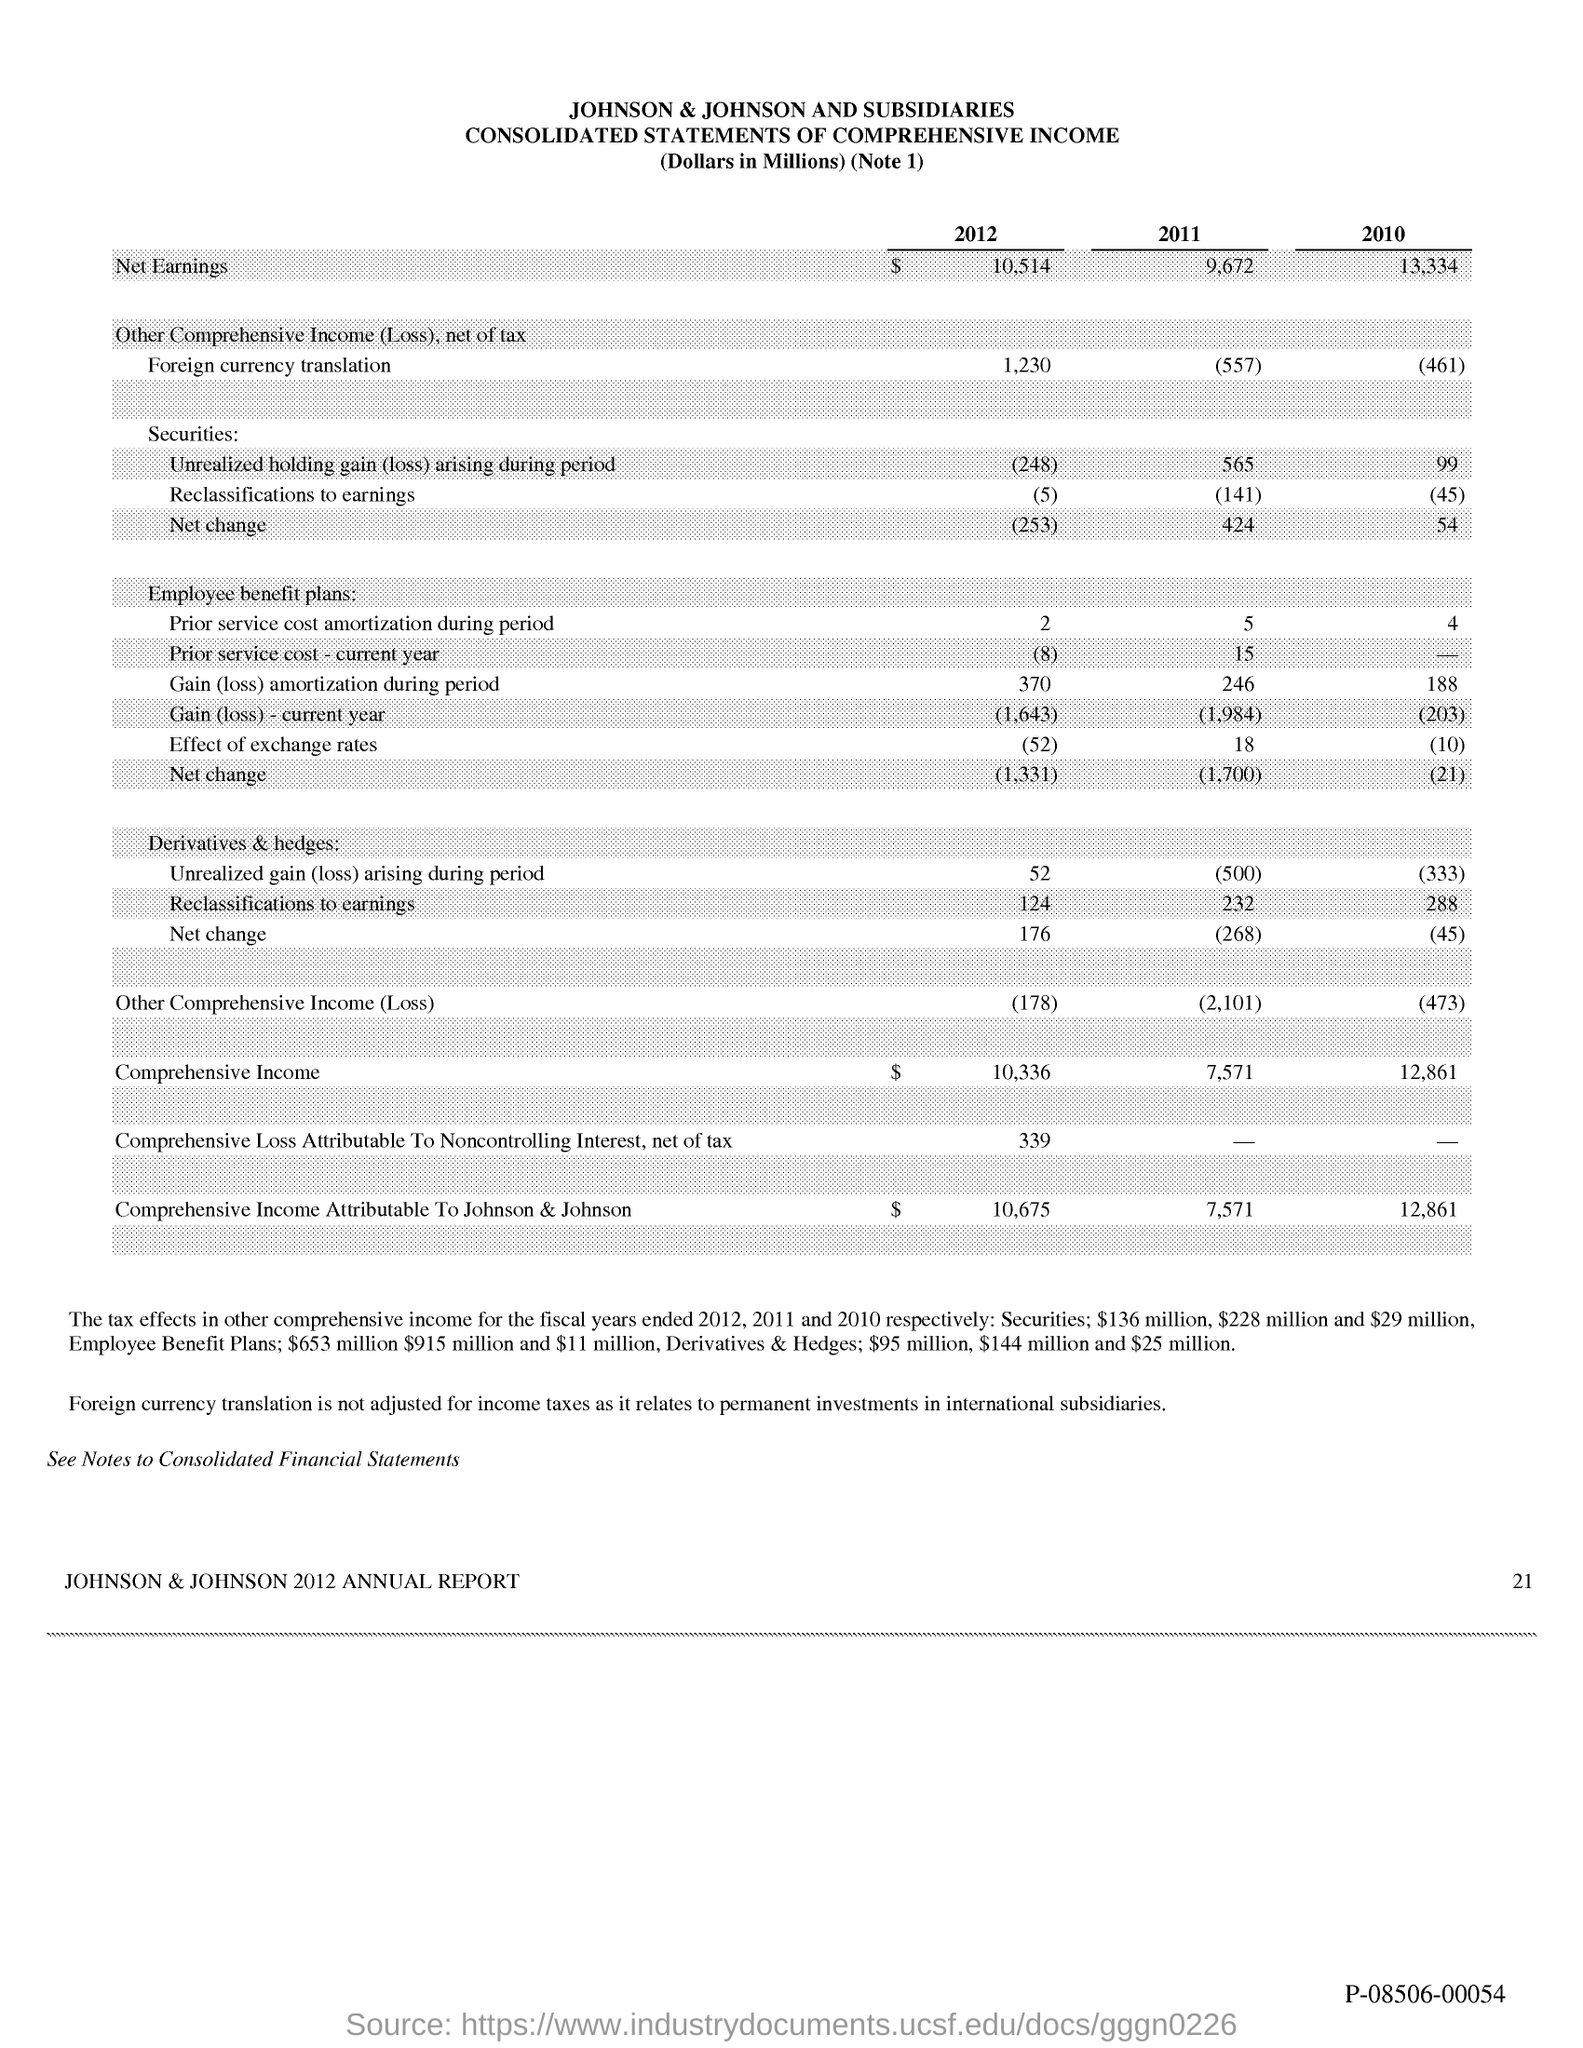What is the Page Number?
Ensure brevity in your answer.  21. 